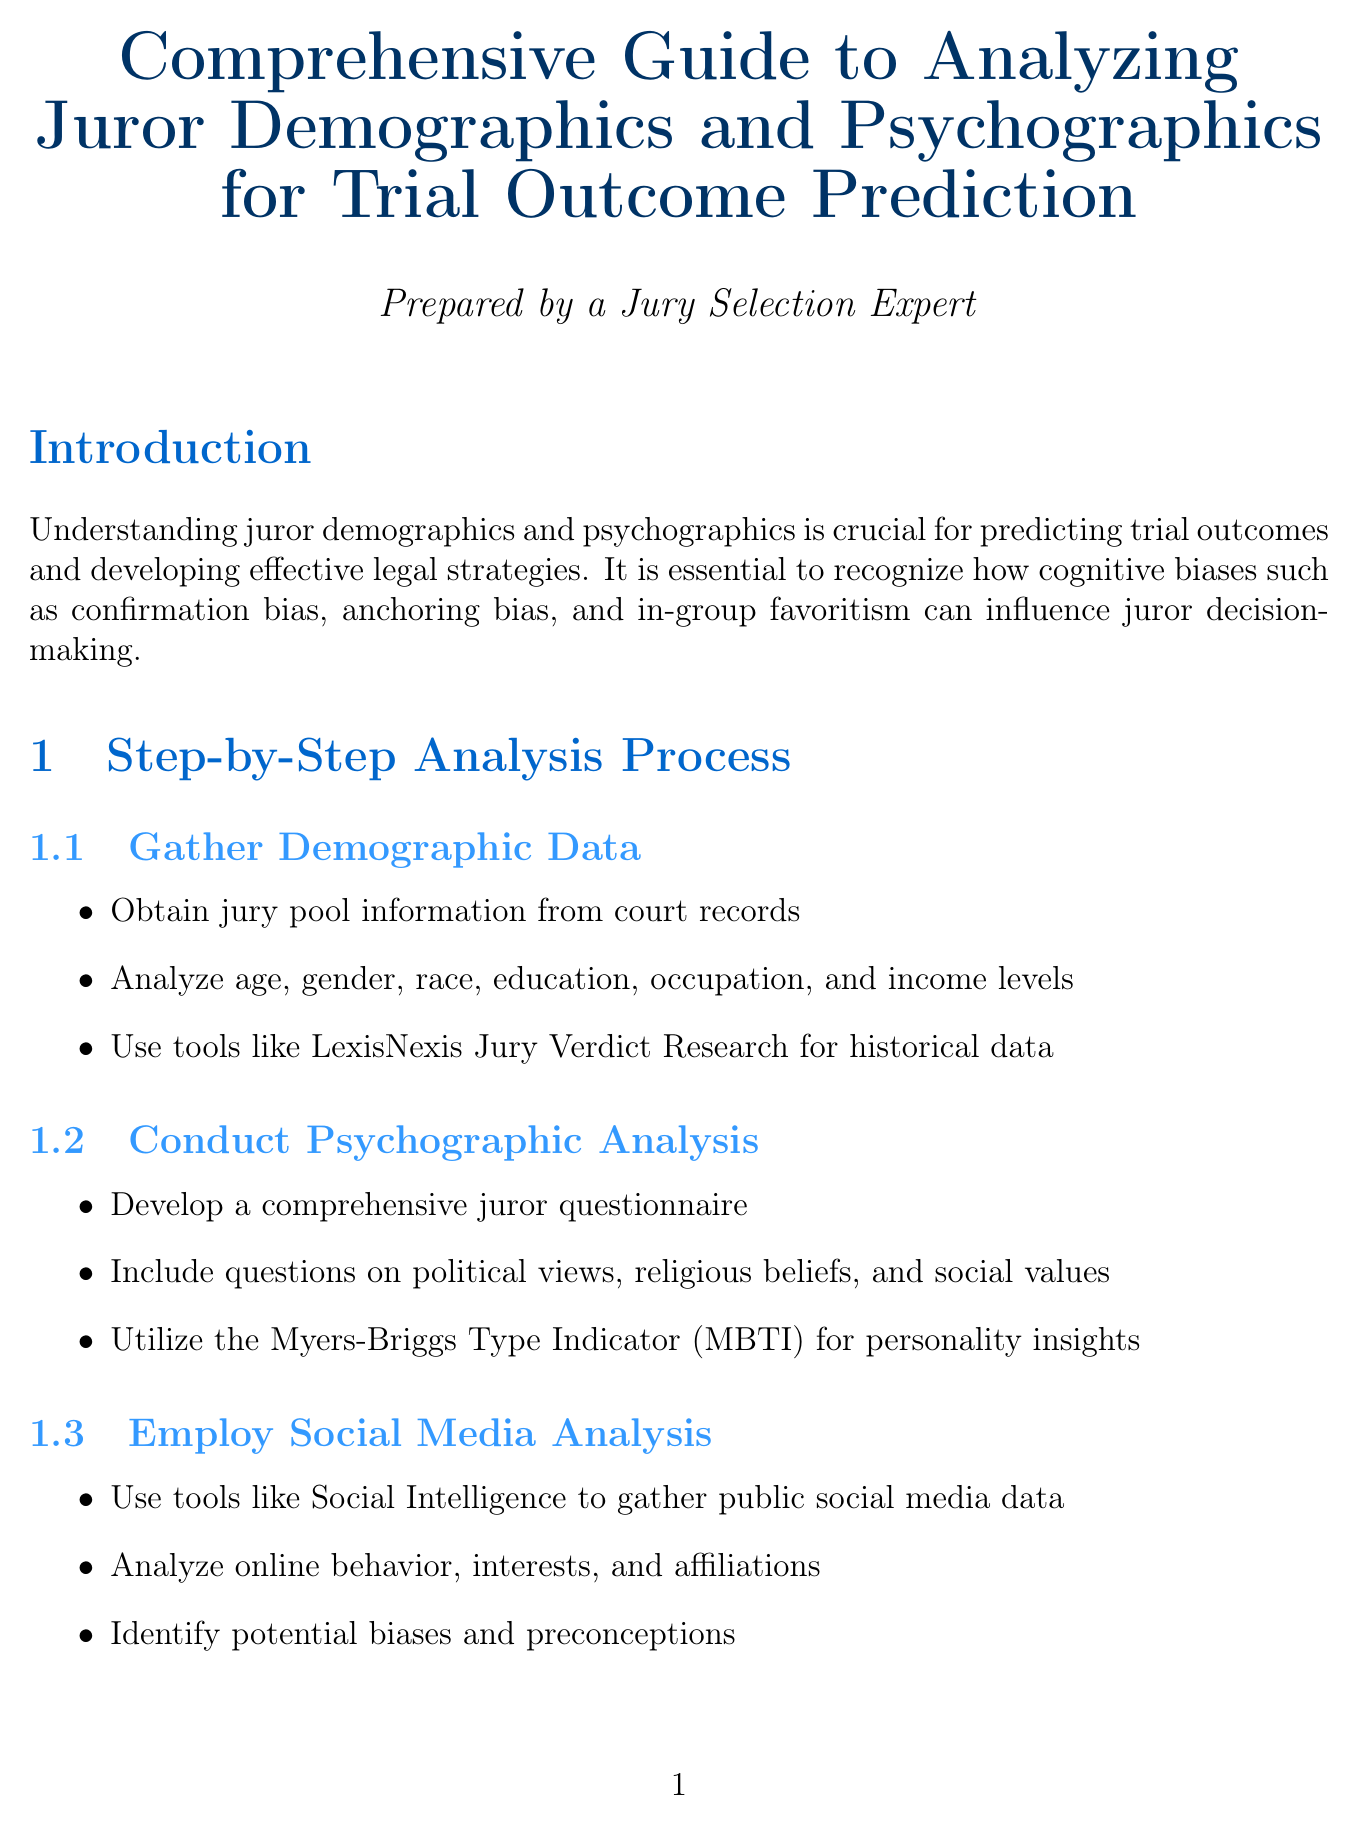what is the title of the manual? The title can be found at the beginning of the document, which presents the main subject of the guide.
Answer: Comprehensive Guide to Analyzing Juror Demographics and Psychographics for Trial Outcome Prediction what is one tool suggested for gathering demographic data? The document lists specific tools or methods to gather demographic data which are mentioned under the substeps.
Answer: LexisNexis Jury Verdict Research which cognitive bias is mentioned first in the introduction? The introduction outlines various cognitive biases affecting juror decision-making, listed sequentially.
Answer: confirmation bias how many case studies are provided in the manual? The section on case studies specifies the number of examples included to illustrate the analysis process.
Answer: 2 what is the first step in the analysis process? The steps are systematically organized in the document, indicating the order of actions to take for analysis.
Answer: Gather Demographic Data what type of analysis does the Myers-Briggs Type Indicator (MBTI) provide? The document includes a substep related to psychographic analysis, identifying the specific kind of insights gained from this tool.
Answer: personality insights name one ethical consideration mentioned in the manual. Ethical considerations are explicitly listed in a section of the document addressing the importance of compliance and fairness in jury analysis.
Answer: Ensure compliance with all legal and ethical guidelines regarding jury selection what is a best practice suggested for jury selection? The best practices are outlined as recommendations for refining the jury selection process.
Answer: Regularly update your knowledge of current events and societal trends 